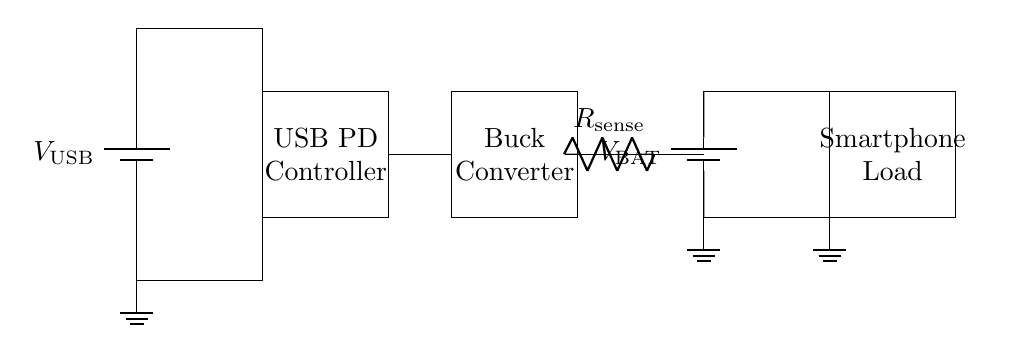What is the main purpose of the USB PD Controller? The USB PD Controller manages power delivery and communication between the power source and the device, adjusting the voltage and current as needed for efficient charging.
Answer: Power management What type of converter is used in this circuit? The diagram depicts a Buck Converter, which steps down the voltage from the input supply to a lower output voltage suitable for the battery.
Answer: Buck Converter What is the role of the current sense resistor in this circuit? The current sense resistor is used to measure the current flowing to the battery or load, enabling monitoring and control of charging current.
Answer: Current measurement How many batteries are in this circuit? There are two batteries shown in the circuit; the USB power source and the battery providing power to the smartphone.
Answer: Two What component is shown to monitor voltage changes during charging? The component that helps in monitoring voltage changes during charging is the Buck Converter, which adjusts the output voltage based on the requirements of the battery or load.
Answer: Buck Converter What does the smartphone load represent in this circuit? The smartphone load represents the device that is being charged by the circuit, drawing power from the battery.
Answer: Smartphone What is the voltage source used in this circuit? The voltage source used in this circuit is labeled as V USB, which indicates the USB power supply voltage provided to the circuit.
Answer: V USB 